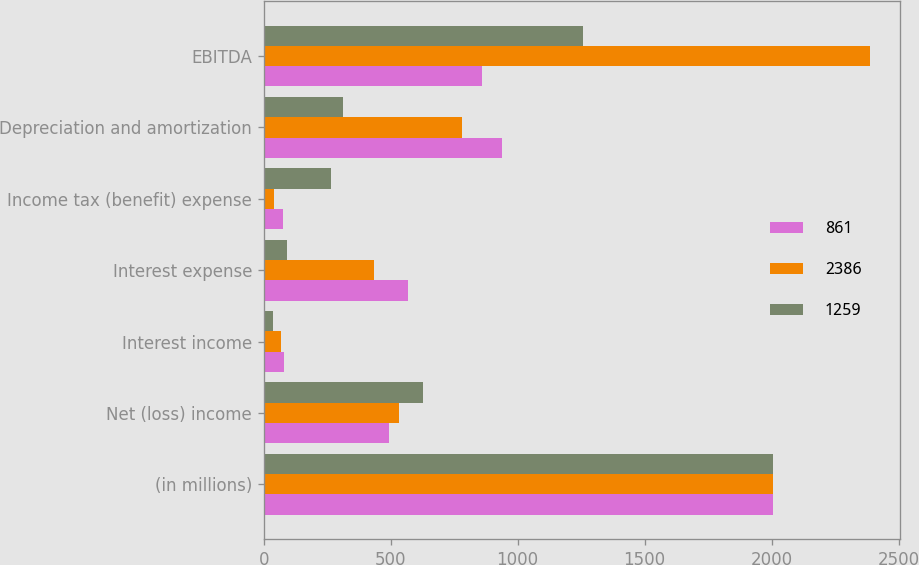Convert chart to OTSL. <chart><loc_0><loc_0><loc_500><loc_500><stacked_bar_chart><ecel><fcel>(in millions)<fcel>Net (loss) income<fcel>Interest income<fcel>Interest expense<fcel>Income tax (benefit) expense<fcel>Depreciation and amortization<fcel>EBITDA<nl><fcel>861<fcel>2007<fcel>495<fcel>79<fcel>570<fcel>74<fcel>939<fcel>861<nl><fcel>2386<fcel>2006<fcel>532.5<fcel>67<fcel>435<fcel>42<fcel>781<fcel>2386<nl><fcel>1259<fcel>2005<fcel>628<fcel>36<fcel>90<fcel>263<fcel>314<fcel>1259<nl></chart> 